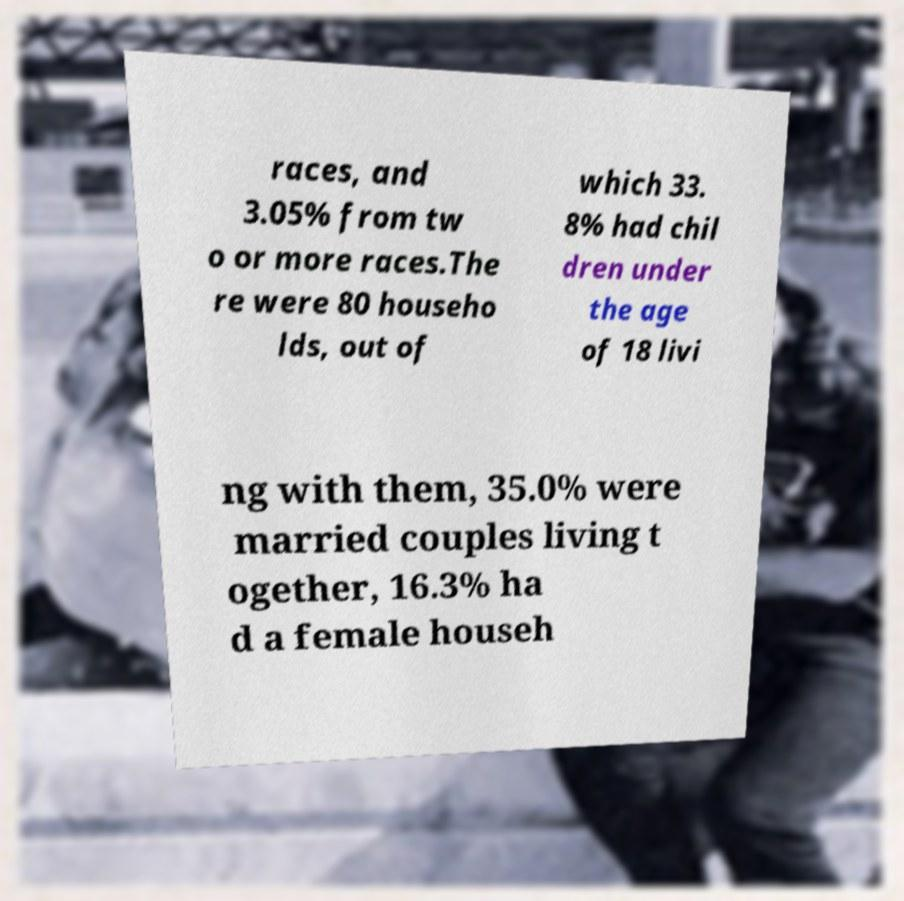I need the written content from this picture converted into text. Can you do that? races, and 3.05% from tw o or more races.The re were 80 househo lds, out of which 33. 8% had chil dren under the age of 18 livi ng with them, 35.0% were married couples living t ogether, 16.3% ha d a female househ 